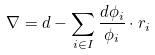<formula> <loc_0><loc_0><loc_500><loc_500>\nabla = d - \sum _ { i \in I } \frac { d \phi _ { i } } { \phi _ { i } } \cdot r _ { i }</formula> 